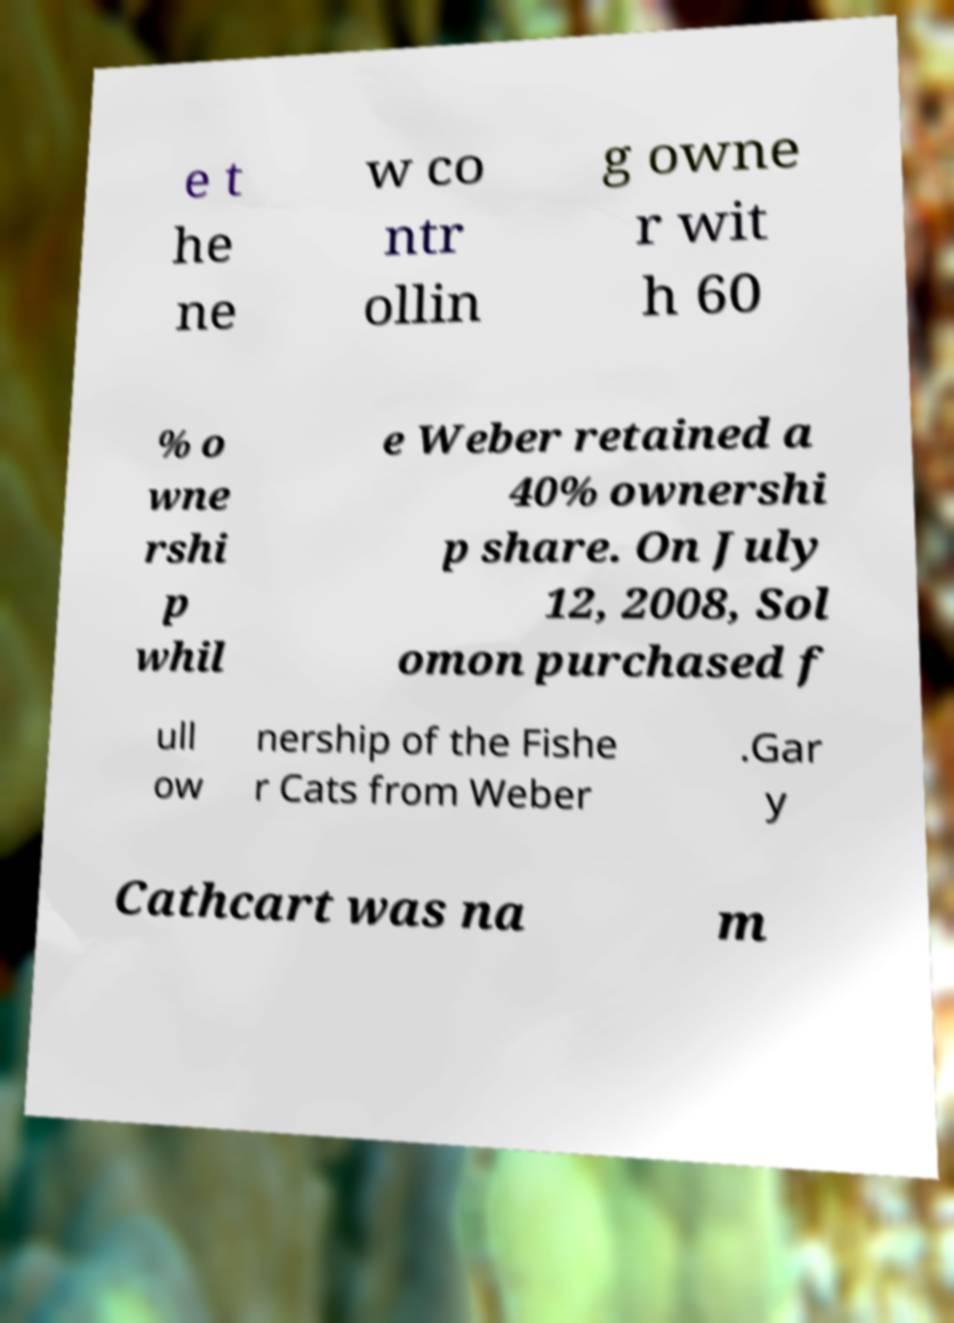Can you read and provide the text displayed in the image?This photo seems to have some interesting text. Can you extract and type it out for me? e t he ne w co ntr ollin g owne r wit h 60 % o wne rshi p whil e Weber retained a 40% ownershi p share. On July 12, 2008, Sol omon purchased f ull ow nership of the Fishe r Cats from Weber .Gar y Cathcart was na m 